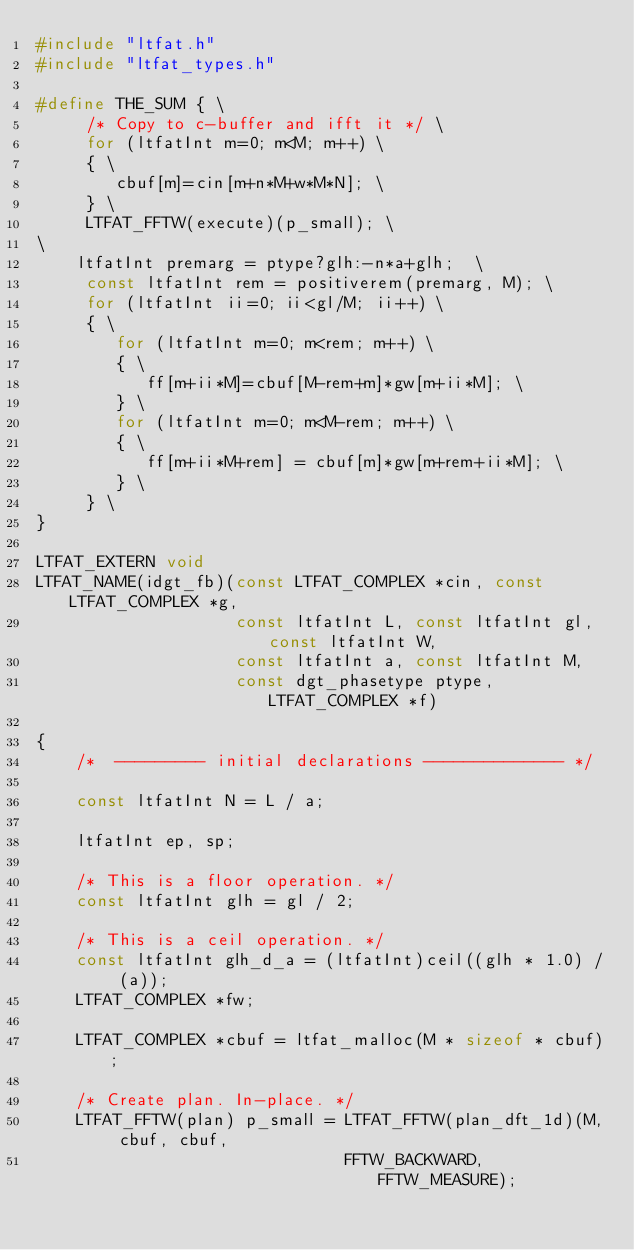Convert code to text. <code><loc_0><loc_0><loc_500><loc_500><_C_>#include "ltfat.h"
#include "ltfat_types.h"

#define THE_SUM { \
     /* Copy to c-buffer and ifft it */ \
     for (ltfatInt m=0; m<M; m++) \
     { \
        cbuf[m]=cin[m+n*M+w*M*N]; \
     } \
     LTFAT_FFTW(execute)(p_small); \
\
    ltfatInt premarg = ptype?glh:-n*a+glh;  \
     const ltfatInt rem = positiverem(premarg, M); \
     for (ltfatInt ii=0; ii<gl/M; ii++) \
     { \
        for (ltfatInt m=0; m<rem; m++) \
        { \
           ff[m+ii*M]=cbuf[M-rem+m]*gw[m+ii*M]; \
        } \
        for (ltfatInt m=0; m<M-rem; m++) \
        { \
           ff[m+ii*M+rem] = cbuf[m]*gw[m+rem+ii*M]; \
        } \
     } \
}

LTFAT_EXTERN void
LTFAT_NAME(idgt_fb)(const LTFAT_COMPLEX *cin, const LTFAT_COMPLEX *g,
                    const ltfatInt L, const ltfatInt gl, const ltfatInt W,
                    const ltfatInt a, const ltfatInt M,
                    const dgt_phasetype ptype, LTFAT_COMPLEX *f)

{
    /*  --------- initial declarations -------------- */

    const ltfatInt N = L / a;

    ltfatInt ep, sp;

    /* This is a floor operation. */
    const ltfatInt glh = gl / 2;

    /* This is a ceil operation. */
    const ltfatInt glh_d_a = (ltfatInt)ceil((glh * 1.0) / (a));
    LTFAT_COMPLEX *fw;

    LTFAT_COMPLEX *cbuf = ltfat_malloc(M * sizeof * cbuf);

    /* Create plan. In-place. */
    LTFAT_FFTW(plan) p_small = LTFAT_FFTW(plan_dft_1d)(M, cbuf, cbuf,
                               FFTW_BACKWARD, FFTW_MEASURE);
</code> 